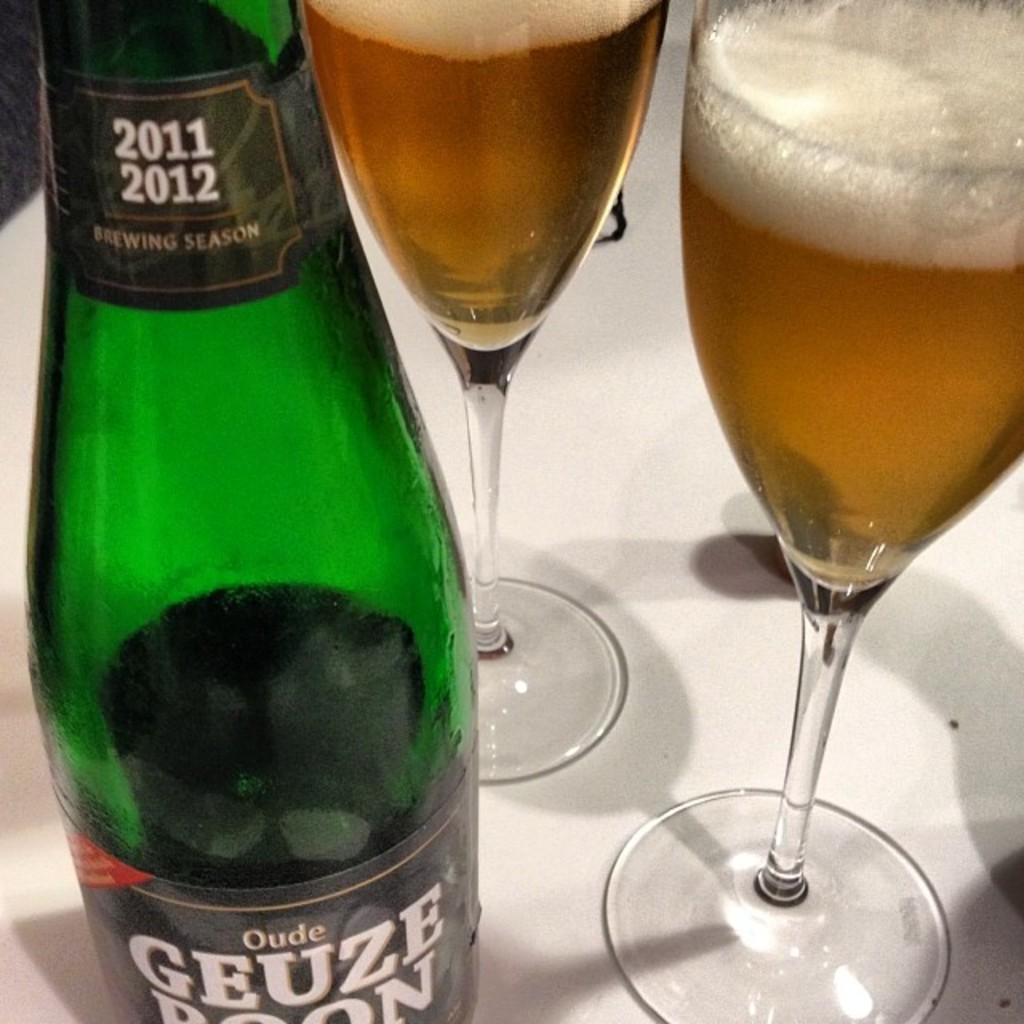What is the main object in the image? There is a bottle in the image. Are there any other objects related to the bottle? Yes, there are two glasses in the image. What is inside the glasses? There is a liquid present in the glasses. What type of tooth is visible in the image? There is no tooth present in the image. What is the condition of the salt in the image? There is no salt present in the image. 